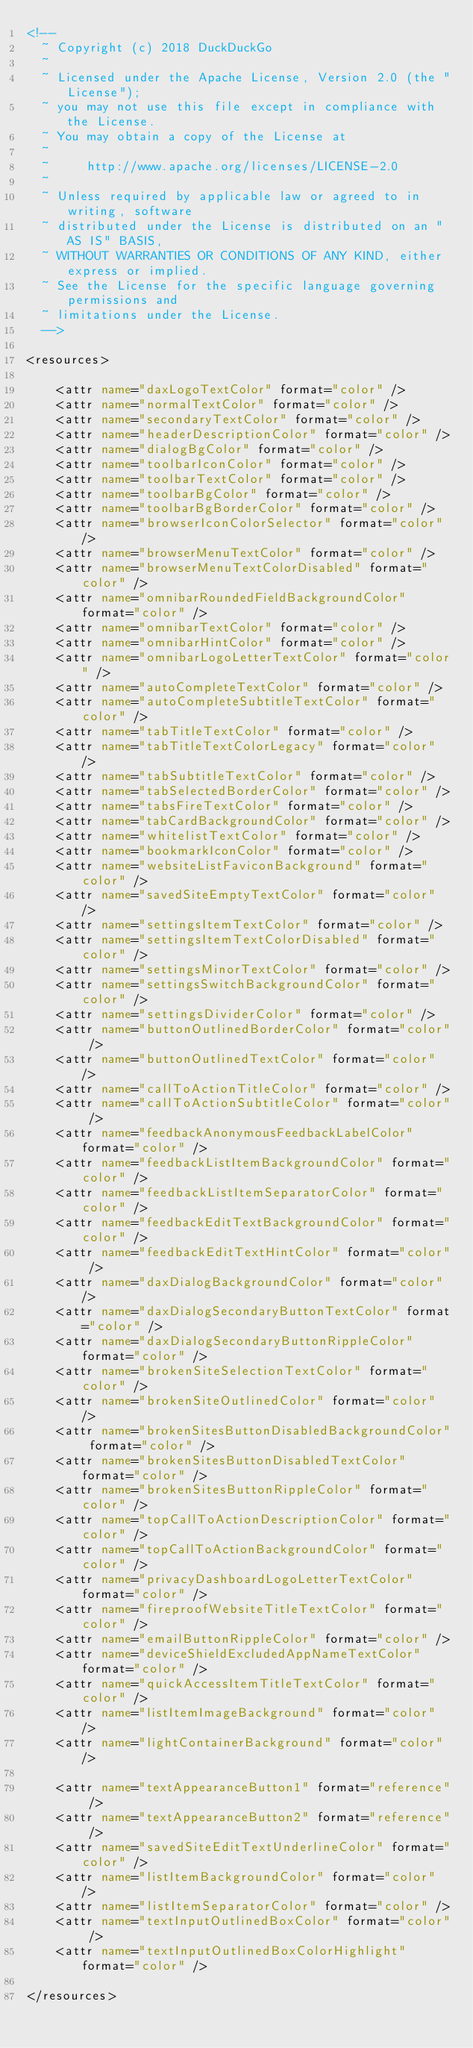<code> <loc_0><loc_0><loc_500><loc_500><_XML_><!--
  ~ Copyright (c) 2018 DuckDuckGo
  ~
  ~ Licensed under the Apache License, Version 2.0 (the "License");
  ~ you may not use this file except in compliance with the License.
  ~ You may obtain a copy of the License at
  ~
  ~     http://www.apache.org/licenses/LICENSE-2.0
  ~
  ~ Unless required by applicable law or agreed to in writing, software
  ~ distributed under the License is distributed on an "AS IS" BASIS,
  ~ WITHOUT WARRANTIES OR CONDITIONS OF ANY KIND, either express or implied.
  ~ See the License for the specific language governing permissions and
  ~ limitations under the License.
  -->

<resources>

    <attr name="daxLogoTextColor" format="color" />
    <attr name="normalTextColor" format="color" />
    <attr name="secondaryTextColor" format="color" />
    <attr name="headerDescriptionColor" format="color" />
    <attr name="dialogBgColor" format="color" />
    <attr name="toolbarIconColor" format="color" />
    <attr name="toolbarTextColor" format="color" />
    <attr name="toolbarBgColor" format="color" />
    <attr name="toolbarBgBorderColor" format="color" />
    <attr name="browserIconColorSelector" format="color" />
    <attr name="browserMenuTextColor" format="color" />
    <attr name="browserMenuTextColorDisabled" format="color" />
    <attr name="omnibarRoundedFieldBackgroundColor" format="color" />
    <attr name="omnibarTextColor" format="color" />
    <attr name="omnibarHintColor" format="color" />
    <attr name="omnibarLogoLetterTextColor" format="color" />
    <attr name="autoCompleteTextColor" format="color" />
    <attr name="autoCompleteSubtitleTextColor" format="color" />
    <attr name="tabTitleTextColor" format="color" />
    <attr name="tabTitleTextColorLegacy" format="color" />
    <attr name="tabSubtitleTextColor" format="color" />
    <attr name="tabSelectedBorderColor" format="color" />
    <attr name="tabsFireTextColor" format="color" />
    <attr name="tabCardBackgroundColor" format="color" />
    <attr name="whitelistTextColor" format="color" />
    <attr name="bookmarkIconColor" format="color" />
    <attr name="websiteListFaviconBackground" format="color" />
    <attr name="savedSiteEmptyTextColor" format="color" />
    <attr name="settingsItemTextColor" format="color" />
    <attr name="settingsItemTextColorDisabled" format="color" />
    <attr name="settingsMinorTextColor" format="color" />
    <attr name="settingsSwitchBackgroundColor" format="color" />
    <attr name="settingsDividerColor" format="color" />
    <attr name="buttonOutlinedBorderColor" format="color" />
    <attr name="buttonOutlinedTextColor" format="color" />
    <attr name="callToActionTitleColor" format="color" />
    <attr name="callToActionSubtitleColor" format="color" />
    <attr name="feedbackAnonymousFeedbackLabelColor" format="color" />
    <attr name="feedbackListItemBackgroundColor" format="color" />
    <attr name="feedbackListItemSeparatorColor" format="color" />
    <attr name="feedbackEditTextBackgroundColor" format="color" />
    <attr name="feedbackEditTextHintColor" format="color" />
    <attr name="daxDialogBackgroundColor" format="color" />
    <attr name="daxDialogSecondaryButtonTextColor" format="color" />
    <attr name="daxDialogSecondaryButtonRippleColor" format="color" />
    <attr name="brokenSiteSelectionTextColor" format="color" />
    <attr name="brokenSiteOutlinedColor" format="color" />
    <attr name="brokenSitesButtonDisabledBackgroundColor" format="color" />
    <attr name="brokenSitesButtonDisabledTextColor" format="color" />
    <attr name="brokenSitesButtonRippleColor" format="color" />
    <attr name="topCallToActionDescriptionColor" format="color" />
    <attr name="topCallToActionBackgroundColor" format="color" />
    <attr name="privacyDashboardLogoLetterTextColor" format="color" />
    <attr name="fireproofWebsiteTitleTextColor" format="color" />
    <attr name="emailButtonRippleColor" format="color" />
    <attr name="deviceShieldExcludedAppNameTextColor" format="color" />
    <attr name="quickAccessItemTitleTextColor" format="color" />
    <attr name="listItemImageBackground" format="color" />
    <attr name="lightContainerBackground" format="color" />

    <attr name="textAppearanceButton1" format="reference" />
    <attr name="textAppearanceButton2" format="reference" />
    <attr name="savedSiteEditTextUnderlineColor" format="color" />
    <attr name="listItemBackgroundColor" format="color" />
    <attr name="listItemSeparatorColor" format="color" />
    <attr name="textInputOutlinedBoxColor" format="color" />
    <attr name="textInputOutlinedBoxColorHighlight" format="color" />

</resources>
</code> 